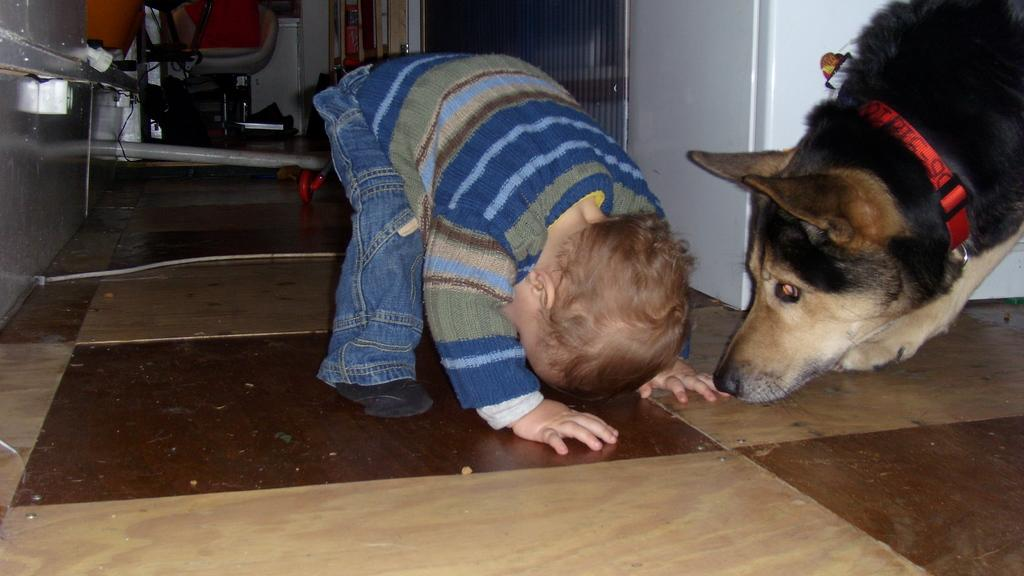What is the main subject of the image? There is a child in the image. What is the child doing in the image? The child is standing. Are there any animals in the image? Yes, there is a dog in the image. How is the child positioned in relation to the dog? The child is standing in front of the dog. What type of cloud can be seen in the image? There is no cloud present in the image; it features a child standing in front of a dog. Is there a desk visible in the image? There is no desk present in the image. 